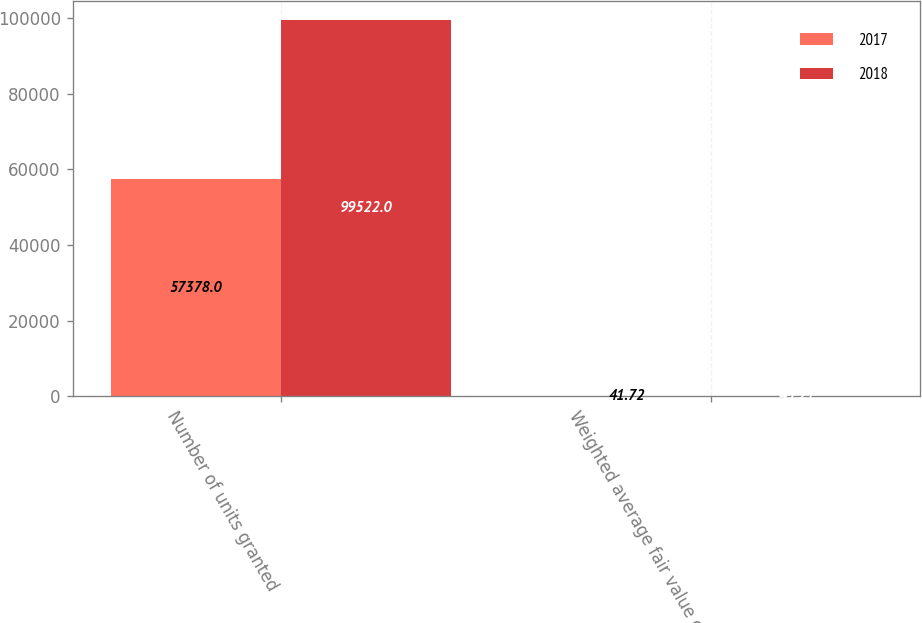Convert chart. <chart><loc_0><loc_0><loc_500><loc_500><stacked_bar_chart><ecel><fcel>Number of units granted<fcel>Weighted average fair value on<nl><fcel>2017<fcel>57378<fcel>41.72<nl><fcel>2018<fcel>99522<fcel>45.21<nl></chart> 